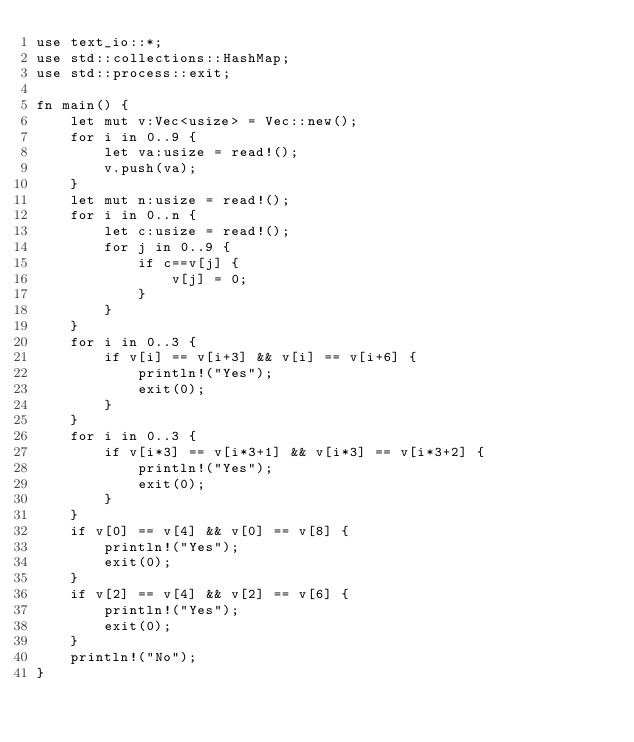<code> <loc_0><loc_0><loc_500><loc_500><_Rust_>use text_io::*;
use std::collections::HashMap;
use std::process::exit;

fn main() {
    let mut v:Vec<usize> = Vec::new();
    for i in 0..9 {
        let va:usize = read!();
        v.push(va);
    }
    let mut n:usize = read!();
    for i in 0..n {
        let c:usize = read!();
        for j in 0..9 {
            if c==v[j] {
                v[j] = 0;
            }
        }
    }
    for i in 0..3 {
        if v[i] == v[i+3] && v[i] == v[i+6] {
            println!("Yes");
            exit(0);
        }
    }
    for i in 0..3 {
        if v[i*3] == v[i*3+1] && v[i*3] == v[i*3+2] {
            println!("Yes");
            exit(0);
        }
    }
    if v[0] == v[4] && v[0] == v[8] {
        println!("Yes");
        exit(0);
    }
    if v[2] == v[4] && v[2] == v[6] {
        println!("Yes");
        exit(0);
    }
    println!("No");
}</code> 